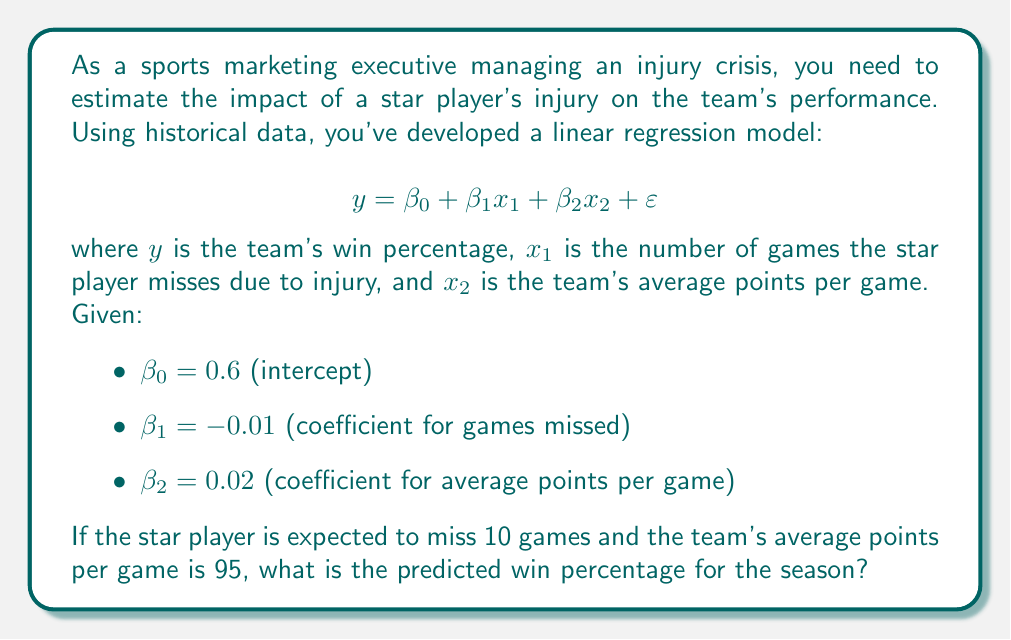Teach me how to tackle this problem. To solve this problem, we'll use the given linear regression model and substitute the known values:

1. Recall the linear regression equation:
   $$ y = \beta_0 + \beta_1x_1 + \beta_2x_2 + \varepsilon $$

2. We're given the following values:
   - $\beta_0 = 0.6$ (intercept)
   - $\beta_1 = -0.01$ (coefficient for games missed)
   - $\beta_2 = 0.02$ (coefficient for average points per game)
   - $x_1 = 10$ (expected games missed by the star player)
   - $x_2 = 95$ (team's average points per game)

3. Substitute these values into the equation:
   $$ y = 0.6 + (-0.01 \times 10) + (0.02 \times 95) + \varepsilon $$

4. Simplify:
   $$ y = 0.6 + (-0.1) + 1.9 + \varepsilon $$
   $$ y = 2.4 + \varepsilon $$

5. In linear regression, we typically ignore the error term ($\varepsilon$) when making predictions, as it represents the random variation not explained by the model. Therefore, our final predicted win percentage is:
   $$ y = 2.4 $$

6. Convert the decimal to a percentage:
   $$ 2.4 \times 100\% = 240\% $$

However, this result is not realistic as a win percentage cannot exceed 100%. This suggests that the model may be overfitting or that there are issues with multicollinearity or the scale of the variables. In a real-world scenario, you would need to reassess the model, possibly by normalizing the variables, including interaction terms, or considering non-linear relationships.
Answer: The predicted win percentage is 240%, which is not realistic. This result indicates that the linear regression model needs to be reevaluated and adjusted to provide more accurate and meaningful predictions within the constraints of win percentages (0% to 100%). 